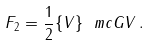Convert formula to latex. <formula><loc_0><loc_0><loc_500><loc_500>F _ { 2 } = \frac { 1 } { 2 } \{ V \} \ m c { G } V \, .</formula> 